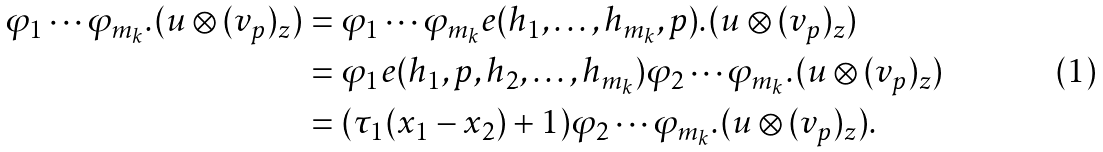Convert formula to latex. <formula><loc_0><loc_0><loc_500><loc_500>\varphi _ { 1 } \cdots \varphi _ { m _ { k } } . ( u \otimes ( v _ { p } ) _ { z } ) & = \varphi _ { 1 } \cdots \varphi _ { m _ { k } } e ( h _ { 1 } , \dots , h _ { m _ { k } } , p ) . ( u \otimes ( v _ { p } ) _ { z } ) \\ & = \varphi _ { 1 } e ( h _ { 1 } , p , h _ { 2 } , \dots , h _ { m _ { k } } ) \varphi _ { 2 } \cdots \varphi _ { m _ { k } } . ( u \otimes ( v _ { p } ) _ { z } ) \\ & = ( \tau _ { 1 } ( x _ { 1 } - x _ { 2 } ) + 1 ) \varphi _ { 2 } \cdots \varphi _ { m _ { k } } . ( u \otimes ( v _ { p } ) _ { z } ) .</formula> 